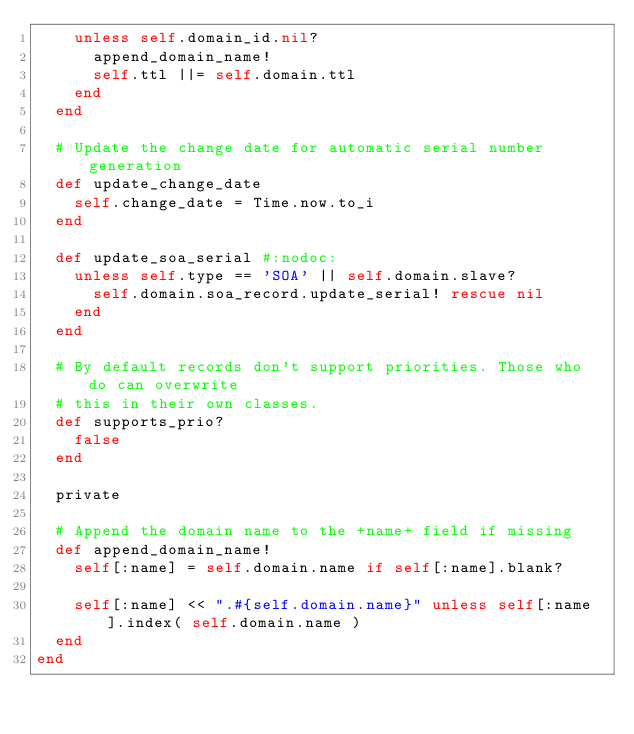<code> <loc_0><loc_0><loc_500><loc_500><_Ruby_>    unless self.domain_id.nil?
      append_domain_name!
      self.ttl ||= self.domain.ttl
    end
  end

  # Update the change date for automatic serial number generation
  def update_change_date
    self.change_date = Time.now.to_i
  end

  def update_soa_serial #:nodoc:
    unless self.type == 'SOA' || self.domain.slave?
      self.domain.soa_record.update_serial! rescue nil
    end
  end

  # By default records don't support priorities. Those who do can overwrite
  # this in their own classes.
  def supports_prio?
    false
  end

  private

  # Append the domain name to the +name+ field if missing
  def append_domain_name!
    self[:name] = self.domain.name if self[:name].blank?

    self[:name] << ".#{self.domain.name}" unless self[:name].index( self.domain.name )
  end
end
</code> 